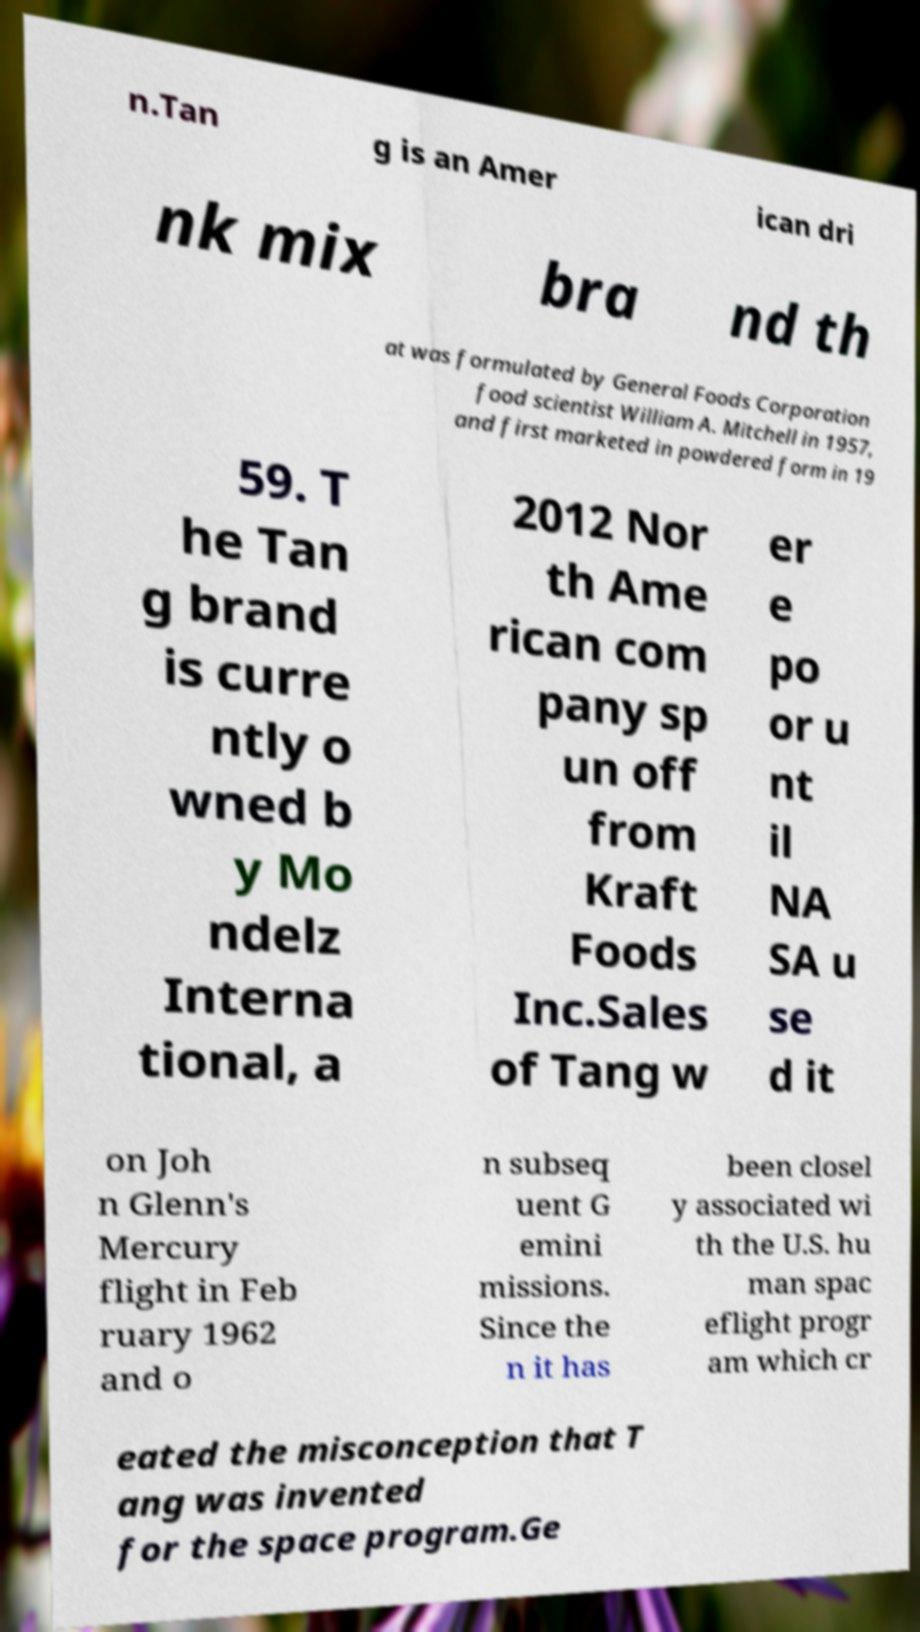What messages or text are displayed in this image? I need them in a readable, typed format. n.Tan g is an Amer ican dri nk mix bra nd th at was formulated by General Foods Corporation food scientist William A. Mitchell in 1957, and first marketed in powdered form in 19 59. T he Tan g brand is curre ntly o wned b y Mo ndelz Interna tional, a 2012 Nor th Ame rican com pany sp un off from Kraft Foods Inc.Sales of Tang w er e po or u nt il NA SA u se d it on Joh n Glenn's Mercury flight in Feb ruary 1962 and o n subseq uent G emini missions. Since the n it has been closel y associated wi th the U.S. hu man spac eflight progr am which cr eated the misconception that T ang was invented for the space program.Ge 